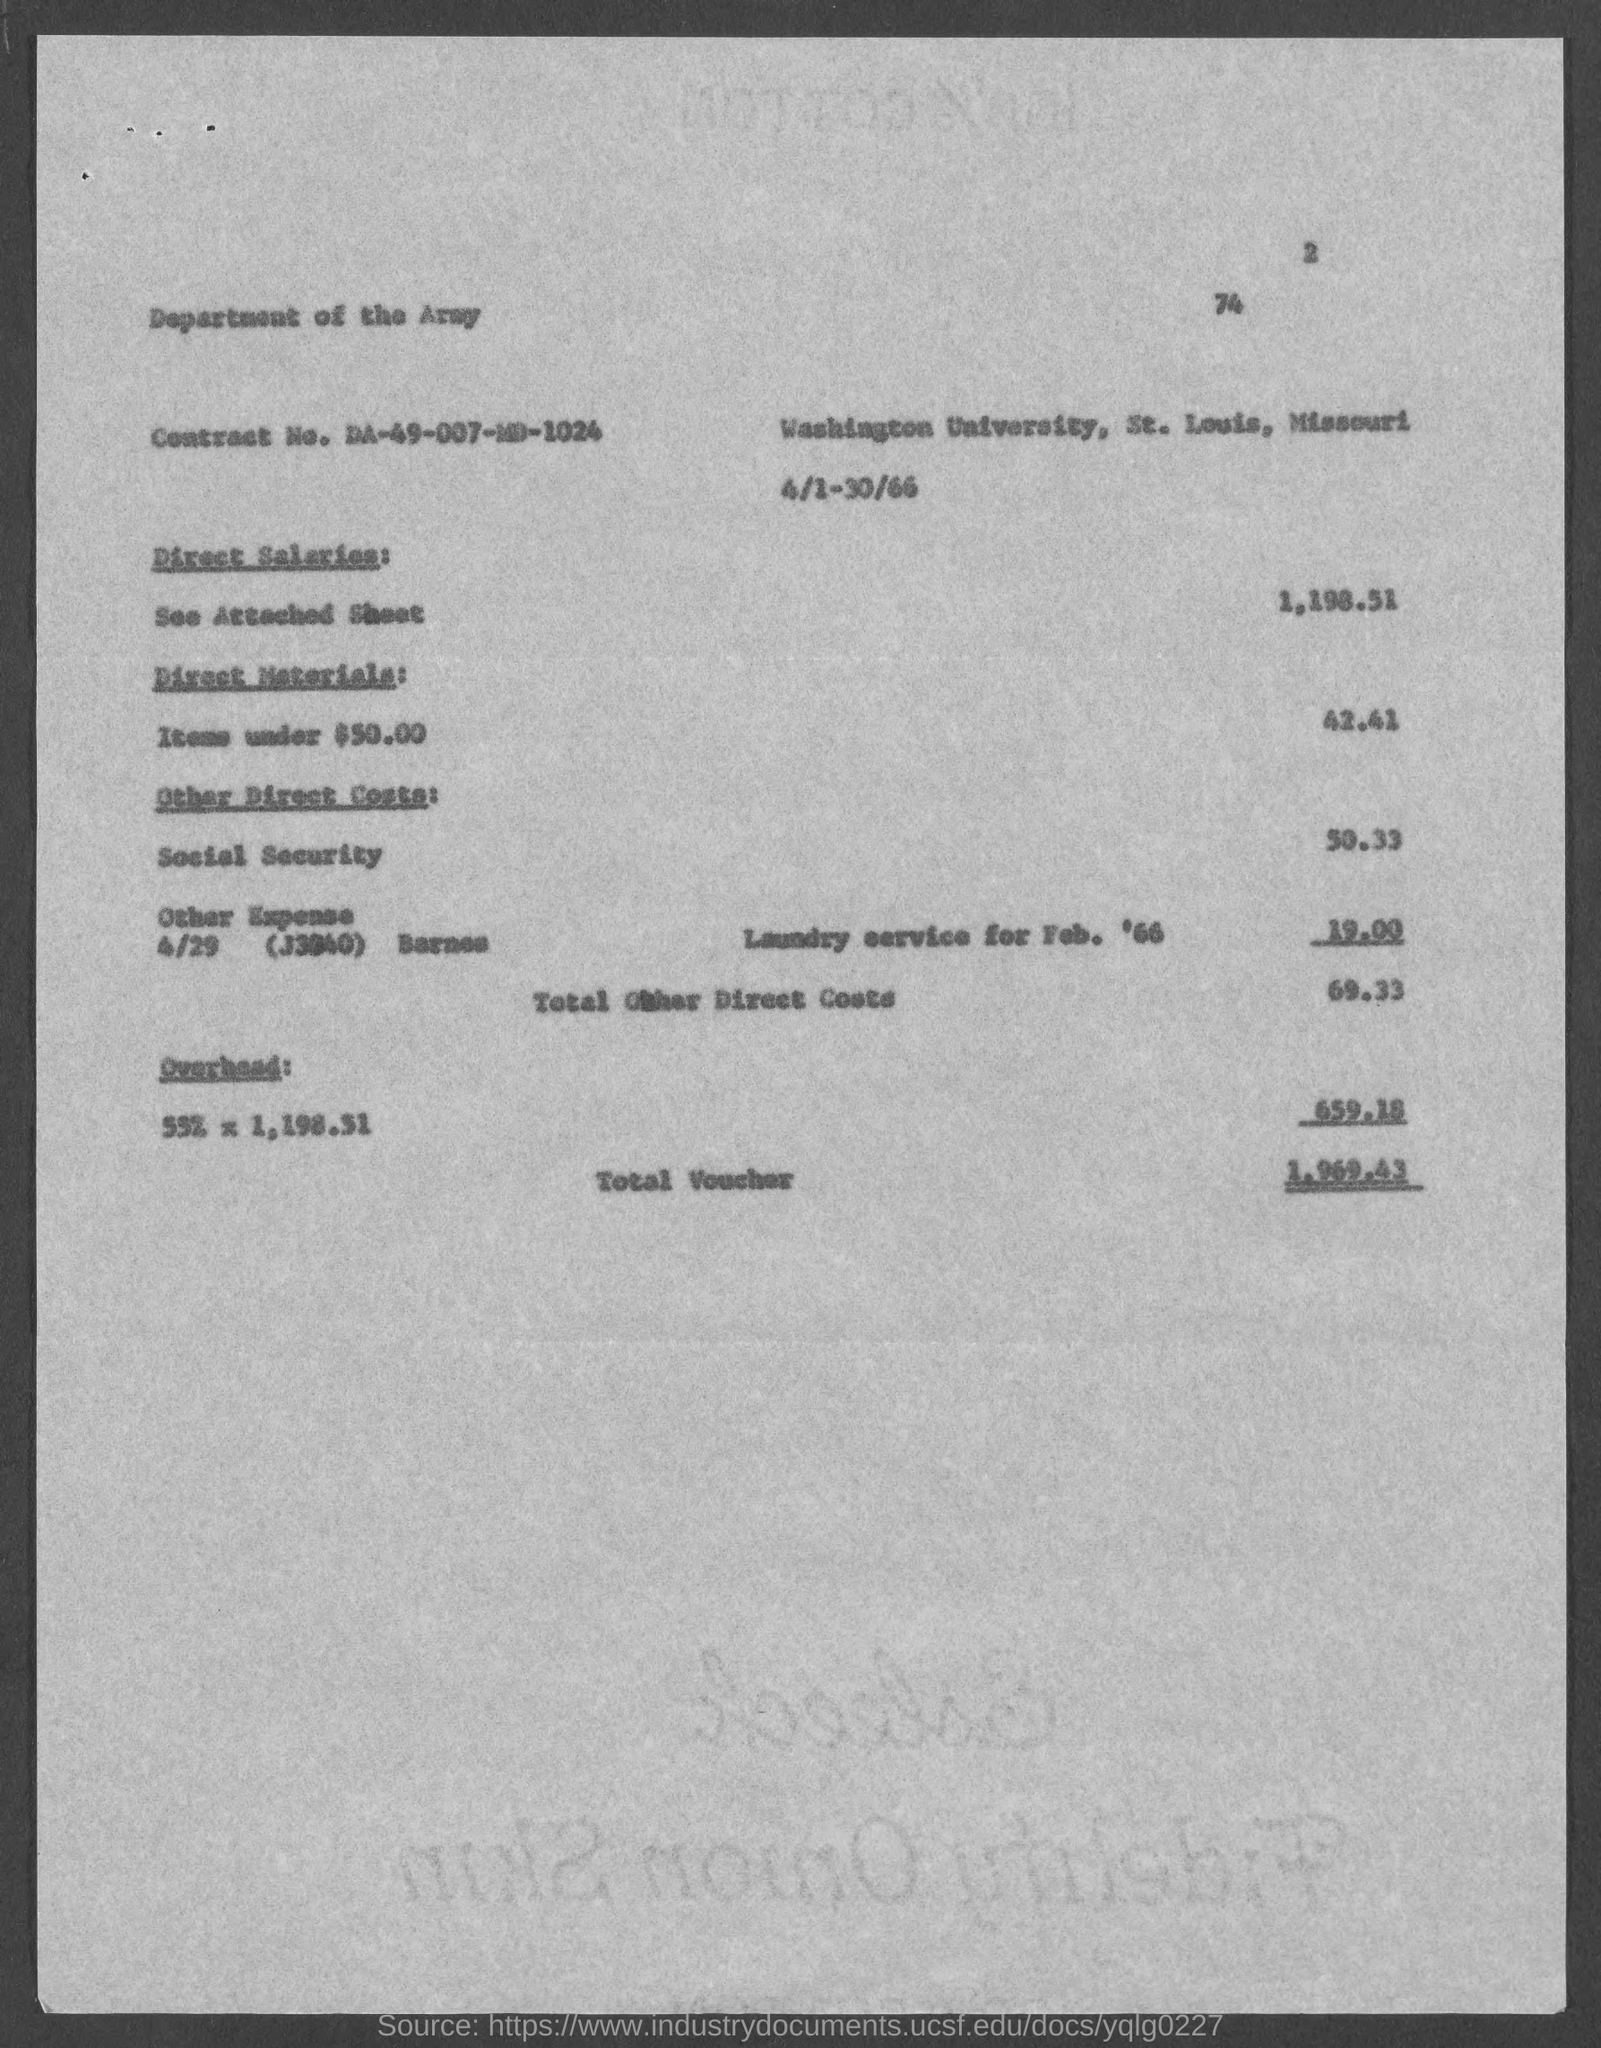What is the page number at top of the page?
Offer a terse response. 2. What is the contract no.?
Give a very brief answer. DA-49-007-MD-1024. What is total voucher amount ?
Ensure brevity in your answer.  1,969.43. 